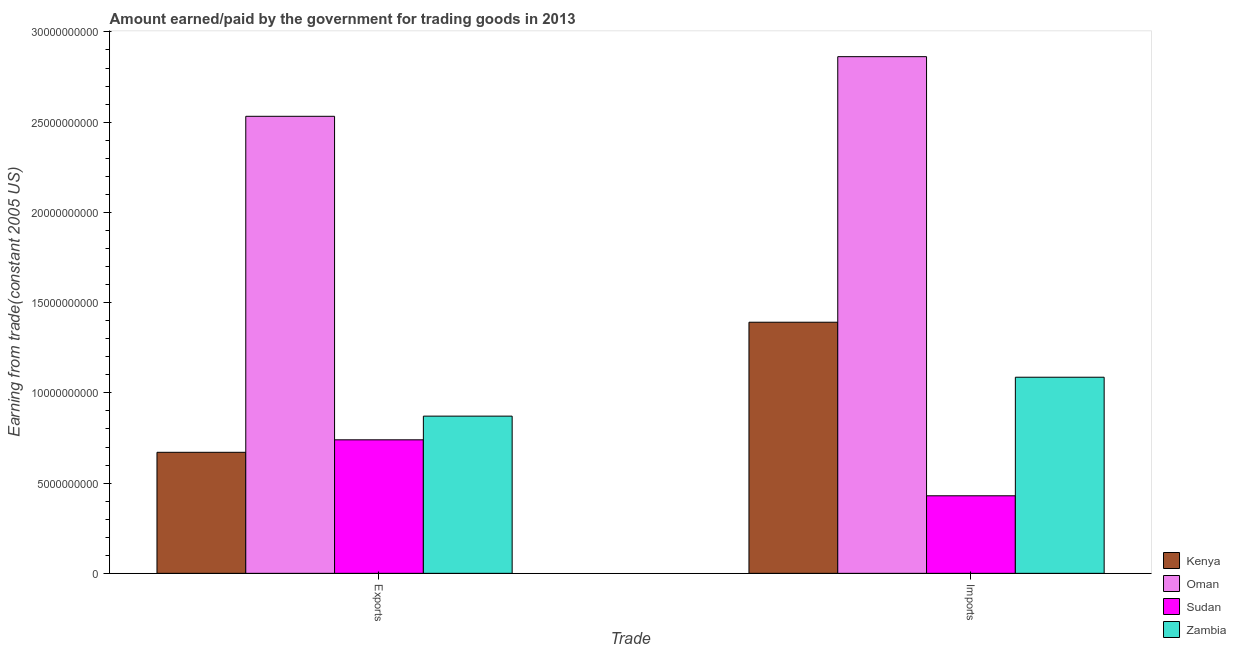Are the number of bars on each tick of the X-axis equal?
Offer a terse response. Yes. How many bars are there on the 1st tick from the left?
Offer a terse response. 4. What is the label of the 2nd group of bars from the left?
Ensure brevity in your answer.  Imports. What is the amount earned from exports in Oman?
Ensure brevity in your answer.  2.53e+1. Across all countries, what is the maximum amount paid for imports?
Provide a succinct answer. 2.86e+1. Across all countries, what is the minimum amount earned from exports?
Your answer should be very brief. 6.71e+09. In which country was the amount earned from exports maximum?
Your answer should be very brief. Oman. In which country was the amount earned from exports minimum?
Your response must be concise. Kenya. What is the total amount paid for imports in the graph?
Your answer should be compact. 5.77e+1. What is the difference between the amount earned from exports in Oman and that in Zambia?
Your answer should be compact. 1.66e+1. What is the difference between the amount earned from exports in Zambia and the amount paid for imports in Kenya?
Make the answer very short. -5.20e+09. What is the average amount earned from exports per country?
Provide a succinct answer. 1.20e+1. What is the difference between the amount paid for imports and amount earned from exports in Oman?
Give a very brief answer. 3.30e+09. In how many countries, is the amount paid for imports greater than 24000000000 US$?
Offer a very short reply. 1. What is the ratio of the amount paid for imports in Kenya to that in Oman?
Offer a very short reply. 0.49. Is the amount paid for imports in Sudan less than that in Zambia?
Give a very brief answer. Yes. What does the 4th bar from the left in Exports represents?
Make the answer very short. Zambia. What does the 3rd bar from the right in Imports represents?
Offer a very short reply. Oman. How many bars are there?
Give a very brief answer. 8. How many countries are there in the graph?
Provide a short and direct response. 4. What is the difference between two consecutive major ticks on the Y-axis?
Keep it short and to the point. 5.00e+09. Does the graph contain any zero values?
Give a very brief answer. No. How many legend labels are there?
Your answer should be very brief. 4. How are the legend labels stacked?
Provide a short and direct response. Vertical. What is the title of the graph?
Ensure brevity in your answer.  Amount earned/paid by the government for trading goods in 2013. Does "Botswana" appear as one of the legend labels in the graph?
Offer a terse response. No. What is the label or title of the X-axis?
Offer a terse response. Trade. What is the label or title of the Y-axis?
Your answer should be compact. Earning from trade(constant 2005 US). What is the Earning from trade(constant 2005 US) in Kenya in Exports?
Give a very brief answer. 6.71e+09. What is the Earning from trade(constant 2005 US) of Oman in Exports?
Ensure brevity in your answer.  2.53e+1. What is the Earning from trade(constant 2005 US) in Sudan in Exports?
Your response must be concise. 7.40e+09. What is the Earning from trade(constant 2005 US) in Zambia in Exports?
Provide a short and direct response. 8.71e+09. What is the Earning from trade(constant 2005 US) in Kenya in Imports?
Your response must be concise. 1.39e+1. What is the Earning from trade(constant 2005 US) in Oman in Imports?
Offer a terse response. 2.86e+1. What is the Earning from trade(constant 2005 US) of Sudan in Imports?
Your answer should be very brief. 4.30e+09. What is the Earning from trade(constant 2005 US) in Zambia in Imports?
Offer a very short reply. 1.09e+1. Across all Trade, what is the maximum Earning from trade(constant 2005 US) of Kenya?
Your answer should be compact. 1.39e+1. Across all Trade, what is the maximum Earning from trade(constant 2005 US) in Oman?
Your answer should be very brief. 2.86e+1. Across all Trade, what is the maximum Earning from trade(constant 2005 US) in Sudan?
Your response must be concise. 7.40e+09. Across all Trade, what is the maximum Earning from trade(constant 2005 US) in Zambia?
Your answer should be very brief. 1.09e+1. Across all Trade, what is the minimum Earning from trade(constant 2005 US) of Kenya?
Your answer should be very brief. 6.71e+09. Across all Trade, what is the minimum Earning from trade(constant 2005 US) of Oman?
Ensure brevity in your answer.  2.53e+1. Across all Trade, what is the minimum Earning from trade(constant 2005 US) in Sudan?
Your answer should be very brief. 4.30e+09. Across all Trade, what is the minimum Earning from trade(constant 2005 US) in Zambia?
Keep it short and to the point. 8.71e+09. What is the total Earning from trade(constant 2005 US) in Kenya in the graph?
Give a very brief answer. 2.06e+1. What is the total Earning from trade(constant 2005 US) in Oman in the graph?
Provide a succinct answer. 5.40e+1. What is the total Earning from trade(constant 2005 US) of Sudan in the graph?
Give a very brief answer. 1.17e+1. What is the total Earning from trade(constant 2005 US) in Zambia in the graph?
Keep it short and to the point. 1.96e+1. What is the difference between the Earning from trade(constant 2005 US) of Kenya in Exports and that in Imports?
Your answer should be compact. -7.21e+09. What is the difference between the Earning from trade(constant 2005 US) of Oman in Exports and that in Imports?
Your answer should be very brief. -3.30e+09. What is the difference between the Earning from trade(constant 2005 US) in Sudan in Exports and that in Imports?
Your response must be concise. 3.10e+09. What is the difference between the Earning from trade(constant 2005 US) of Zambia in Exports and that in Imports?
Your answer should be very brief. -2.16e+09. What is the difference between the Earning from trade(constant 2005 US) in Kenya in Exports and the Earning from trade(constant 2005 US) in Oman in Imports?
Offer a very short reply. -2.19e+1. What is the difference between the Earning from trade(constant 2005 US) in Kenya in Exports and the Earning from trade(constant 2005 US) in Sudan in Imports?
Keep it short and to the point. 2.41e+09. What is the difference between the Earning from trade(constant 2005 US) of Kenya in Exports and the Earning from trade(constant 2005 US) of Zambia in Imports?
Your response must be concise. -4.16e+09. What is the difference between the Earning from trade(constant 2005 US) of Oman in Exports and the Earning from trade(constant 2005 US) of Sudan in Imports?
Your answer should be compact. 2.10e+1. What is the difference between the Earning from trade(constant 2005 US) in Oman in Exports and the Earning from trade(constant 2005 US) in Zambia in Imports?
Provide a succinct answer. 1.45e+1. What is the difference between the Earning from trade(constant 2005 US) in Sudan in Exports and the Earning from trade(constant 2005 US) in Zambia in Imports?
Offer a terse response. -3.47e+09. What is the average Earning from trade(constant 2005 US) of Kenya per Trade?
Provide a short and direct response. 1.03e+1. What is the average Earning from trade(constant 2005 US) of Oman per Trade?
Your answer should be compact. 2.70e+1. What is the average Earning from trade(constant 2005 US) in Sudan per Trade?
Ensure brevity in your answer.  5.85e+09. What is the average Earning from trade(constant 2005 US) in Zambia per Trade?
Give a very brief answer. 9.79e+09. What is the difference between the Earning from trade(constant 2005 US) of Kenya and Earning from trade(constant 2005 US) of Oman in Exports?
Your answer should be compact. -1.86e+1. What is the difference between the Earning from trade(constant 2005 US) of Kenya and Earning from trade(constant 2005 US) of Sudan in Exports?
Ensure brevity in your answer.  -6.92e+08. What is the difference between the Earning from trade(constant 2005 US) of Kenya and Earning from trade(constant 2005 US) of Zambia in Exports?
Ensure brevity in your answer.  -2.00e+09. What is the difference between the Earning from trade(constant 2005 US) of Oman and Earning from trade(constant 2005 US) of Sudan in Exports?
Provide a succinct answer. 1.79e+1. What is the difference between the Earning from trade(constant 2005 US) in Oman and Earning from trade(constant 2005 US) in Zambia in Exports?
Make the answer very short. 1.66e+1. What is the difference between the Earning from trade(constant 2005 US) of Sudan and Earning from trade(constant 2005 US) of Zambia in Exports?
Ensure brevity in your answer.  -1.31e+09. What is the difference between the Earning from trade(constant 2005 US) of Kenya and Earning from trade(constant 2005 US) of Oman in Imports?
Your answer should be very brief. -1.47e+1. What is the difference between the Earning from trade(constant 2005 US) in Kenya and Earning from trade(constant 2005 US) in Sudan in Imports?
Your response must be concise. 9.62e+09. What is the difference between the Earning from trade(constant 2005 US) of Kenya and Earning from trade(constant 2005 US) of Zambia in Imports?
Your response must be concise. 3.05e+09. What is the difference between the Earning from trade(constant 2005 US) of Oman and Earning from trade(constant 2005 US) of Sudan in Imports?
Offer a very short reply. 2.43e+1. What is the difference between the Earning from trade(constant 2005 US) of Oman and Earning from trade(constant 2005 US) of Zambia in Imports?
Offer a very short reply. 1.78e+1. What is the difference between the Earning from trade(constant 2005 US) in Sudan and Earning from trade(constant 2005 US) in Zambia in Imports?
Provide a succinct answer. -6.57e+09. What is the ratio of the Earning from trade(constant 2005 US) in Kenya in Exports to that in Imports?
Offer a very short reply. 0.48. What is the ratio of the Earning from trade(constant 2005 US) in Oman in Exports to that in Imports?
Your answer should be compact. 0.88. What is the ratio of the Earning from trade(constant 2005 US) in Sudan in Exports to that in Imports?
Make the answer very short. 1.72. What is the ratio of the Earning from trade(constant 2005 US) in Zambia in Exports to that in Imports?
Provide a succinct answer. 0.8. What is the difference between the highest and the second highest Earning from trade(constant 2005 US) in Kenya?
Make the answer very short. 7.21e+09. What is the difference between the highest and the second highest Earning from trade(constant 2005 US) in Oman?
Your answer should be very brief. 3.30e+09. What is the difference between the highest and the second highest Earning from trade(constant 2005 US) in Sudan?
Your answer should be very brief. 3.10e+09. What is the difference between the highest and the second highest Earning from trade(constant 2005 US) of Zambia?
Offer a very short reply. 2.16e+09. What is the difference between the highest and the lowest Earning from trade(constant 2005 US) in Kenya?
Give a very brief answer. 7.21e+09. What is the difference between the highest and the lowest Earning from trade(constant 2005 US) of Oman?
Offer a very short reply. 3.30e+09. What is the difference between the highest and the lowest Earning from trade(constant 2005 US) in Sudan?
Make the answer very short. 3.10e+09. What is the difference between the highest and the lowest Earning from trade(constant 2005 US) in Zambia?
Provide a short and direct response. 2.16e+09. 